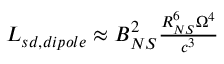Convert formula to latex. <formula><loc_0><loc_0><loc_500><loc_500>\begin{array} { r l r & { L _ { s d , d i p o l e } \approx B _ { N S } ^ { 2 } \frac { R _ { N S } ^ { 6 } \Omega ^ { 4 } } { c ^ { 3 } } } \end{array}</formula> 